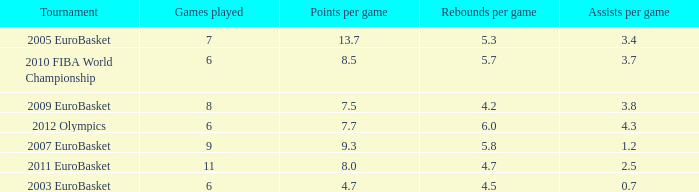Help me parse the entirety of this table. {'header': ['Tournament', 'Games played', 'Points per game', 'Rebounds per game', 'Assists per game'], 'rows': [['2005 EuroBasket', '7', '13.7', '5.3', '3.4'], ['2010 FIBA World Championship', '6', '8.5', '5.7', '3.7'], ['2009 EuroBasket', '8', '7.5', '4.2', '3.8'], ['2012 Olympics', '6', '7.7', '6.0', '4.3'], ['2007 EuroBasket', '9', '9.3', '5.8', '1.2'], ['2011 EuroBasket', '11', '8.0', '4.7', '2.5'], ['2003 EuroBasket', '6', '4.7', '4.5', '0.7']]} How many games played have 4.7 as points per game? 6.0. 